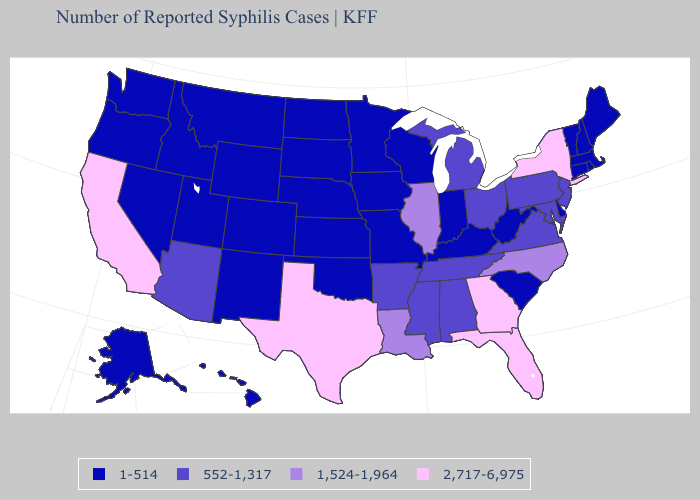What is the value of Idaho?
Be succinct. 1-514. Name the states that have a value in the range 2,717-6,975?
Be succinct. California, Florida, Georgia, New York, Texas. Does the first symbol in the legend represent the smallest category?
Short answer required. Yes. Does Alabama have the same value as Michigan?
Be succinct. Yes. Name the states that have a value in the range 1,524-1,964?
Be succinct. Illinois, Louisiana, North Carolina. Among the states that border Kentucky , does Indiana have the highest value?
Keep it brief. No. Name the states that have a value in the range 552-1,317?
Give a very brief answer. Alabama, Arizona, Arkansas, Maryland, Michigan, Mississippi, New Jersey, Ohio, Pennsylvania, Tennessee, Virginia. What is the lowest value in states that border Missouri?
Keep it brief. 1-514. What is the value of South Dakota?
Keep it brief. 1-514. Name the states that have a value in the range 552-1,317?
Quick response, please. Alabama, Arizona, Arkansas, Maryland, Michigan, Mississippi, New Jersey, Ohio, Pennsylvania, Tennessee, Virginia. What is the value of New Jersey?
Give a very brief answer. 552-1,317. What is the value of Delaware?
Quick response, please. 1-514. Which states have the highest value in the USA?
Short answer required. California, Florida, Georgia, New York, Texas. 